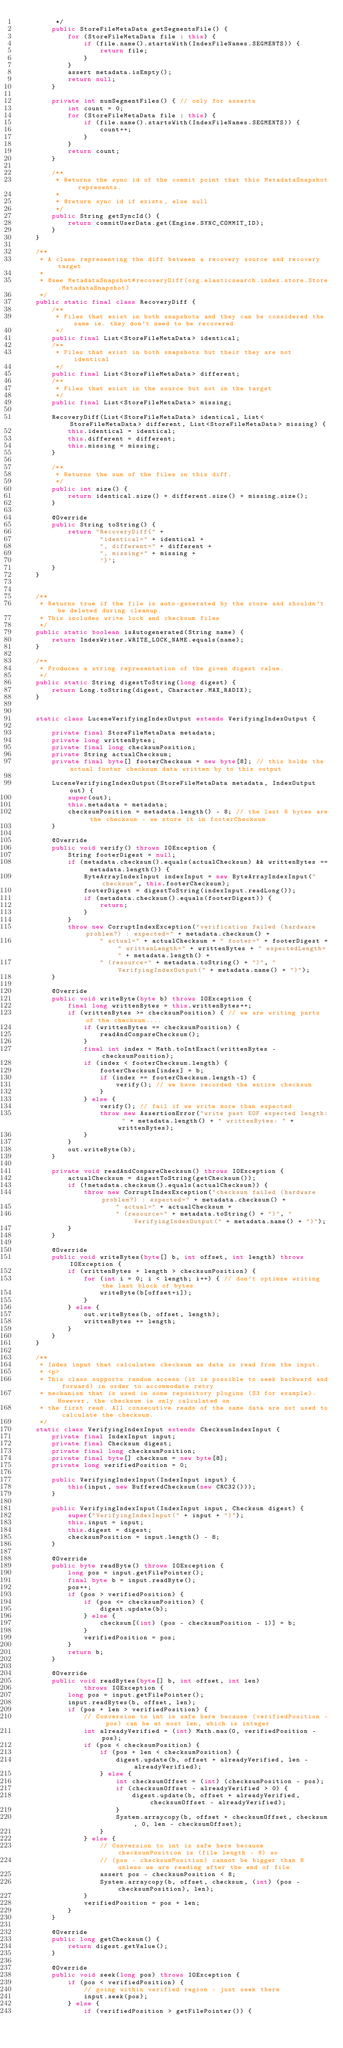Convert code to text. <code><loc_0><loc_0><loc_500><loc_500><_Java_>         */
        public StoreFileMetaData getSegmentsFile() {
            for (StoreFileMetaData file : this) {
                if (file.name().startsWith(IndexFileNames.SEGMENTS)) {
                    return file;
                }
            }
            assert metadata.isEmpty();
            return null;
        }

        private int numSegmentFiles() { // only for asserts
            int count = 0;
            for (StoreFileMetaData file : this) {
                if (file.name().startsWith(IndexFileNames.SEGMENTS)) {
                    count++;
                }
            }
            return count;
        }

        /**
         * Returns the sync id of the commit point that this MetadataSnapshot represents.
         *
         * @return sync id if exists, else null
         */
        public String getSyncId() {
            return commitUserData.get(Engine.SYNC_COMMIT_ID);
        }
    }

    /**
     * A class representing the diff between a recovery source and recovery target
     *
     * @see MetadataSnapshot#recoveryDiff(org.elasticsearch.index.store.Store.MetadataSnapshot)
     */
    public static final class RecoveryDiff {
        /**
         * Files that exist in both snapshots and they can be considered the same ie. they don't need to be recovered
         */
        public final List<StoreFileMetaData> identical;
        /**
         * Files that exist in both snapshots but their they are not identical
         */
        public final List<StoreFileMetaData> different;
        /**
         * Files that exist in the source but not in the target
         */
        public final List<StoreFileMetaData> missing;

        RecoveryDiff(List<StoreFileMetaData> identical, List<StoreFileMetaData> different, List<StoreFileMetaData> missing) {
            this.identical = identical;
            this.different = different;
            this.missing = missing;
        }

        /**
         * Returns the sum of the files in this diff.
         */
        public int size() {
            return identical.size() + different.size() + missing.size();
        }

        @Override
        public String toString() {
            return "RecoveryDiff{" +
                    "identical=" + identical +
                    ", different=" + different +
                    ", missing=" + missing +
                    '}';
        }
    }


    /**
     * Returns true if the file is auto-generated by the store and shouldn't be deleted during cleanup.
     * This includes write lock and checksum files
     */
    public static boolean isAutogenerated(String name) {
        return IndexWriter.WRITE_LOCK_NAME.equals(name);
    }

    /**
     * Produces a string representation of the given digest value.
     */
    public static String digestToString(long digest) {
        return Long.toString(digest, Character.MAX_RADIX);
    }


    static class LuceneVerifyingIndexOutput extends VerifyingIndexOutput {

        private final StoreFileMetaData metadata;
        private long writtenBytes;
        private final long checksumPosition;
        private String actualChecksum;
        private final byte[] footerChecksum = new byte[8]; // this holds the actual footer checksum data written by to this output

        LuceneVerifyingIndexOutput(StoreFileMetaData metadata, IndexOutput out) {
            super(out);
            this.metadata = metadata;
            checksumPosition = metadata.length() - 8; // the last 8 bytes are the checksum - we store it in footerChecksum
        }

        @Override
        public void verify() throws IOException {
            String footerDigest = null;
            if (metadata.checksum().equals(actualChecksum) && writtenBytes == metadata.length()) {
                ByteArrayIndexInput indexInput = new ByteArrayIndexInput("checksum", this.footerChecksum);
                footerDigest = digestToString(indexInput.readLong());
                if (metadata.checksum().equals(footerDigest)) {
                    return;
                }
            }
            throw new CorruptIndexException("verification failed (hardware problem?) : expected=" + metadata.checksum() +
                    " actual=" + actualChecksum + " footer=" + footerDigest +" writtenLength=" + writtenBytes + " expectedLength=" + metadata.length() +
                    " (resource=" + metadata.toString() + ")", "VerifyingIndexOutput(" + metadata.name() + ")");
        }

        @Override
        public void writeByte(byte b) throws IOException {
            final long writtenBytes = this.writtenBytes++;
            if (writtenBytes >= checksumPosition) { // we are writing parts of the checksum....
                if (writtenBytes == checksumPosition) {
                    readAndCompareChecksum();
                }
                final int index = Math.toIntExact(writtenBytes - checksumPosition);
                if (index < footerChecksum.length) {
                    footerChecksum[index] = b;
                    if (index == footerChecksum.length-1) {
                        verify(); // we have recorded the entire checksum
                    }
                } else {
                    verify(); // fail if we write more than expected
                    throw new AssertionError("write past EOF expected length: " + metadata.length() + " writtenBytes: " + writtenBytes);
                }
            }
            out.writeByte(b);
        }

        private void readAndCompareChecksum() throws IOException {
            actualChecksum = digestToString(getChecksum());
            if (!metadata.checksum().equals(actualChecksum)) {
                throw new CorruptIndexException("checksum failed (hardware problem?) : expected=" + metadata.checksum() +
                        " actual=" + actualChecksum +
                        " (resource=" + metadata.toString() + ")", "VerifyingIndexOutput(" + metadata.name() + ")");
            }
        }

        @Override
        public void writeBytes(byte[] b, int offset, int length) throws IOException {
            if (writtenBytes + length > checksumPosition) {
                for (int i = 0; i < length; i++) { // don't optimze writing the last block of bytes
                    writeByte(b[offset+i]);
                }
            } else {
                out.writeBytes(b, offset, length);
                writtenBytes += length;
            }
        }
    }

    /**
     * Index input that calculates checksum as data is read from the input.
     * <p>
     * This class supports random access (it is possible to seek backward and forward) in order to accommodate retry
     * mechanism that is used in some repository plugins (S3 for example). However, the checksum is only calculated on
     * the first read. All consecutive reads of the same data are not used to calculate the checksum.
     */
    static class VerifyingIndexInput extends ChecksumIndexInput {
        private final IndexInput input;
        private final Checksum digest;
        private final long checksumPosition;
        private final byte[] checksum = new byte[8];
        private long verifiedPosition = 0;

        public VerifyingIndexInput(IndexInput input) {
            this(input, new BufferedChecksum(new CRC32()));
        }

        public VerifyingIndexInput(IndexInput input, Checksum digest) {
            super("VerifyingIndexInput(" + input + ")");
            this.input = input;
            this.digest = digest;
            checksumPosition = input.length() - 8;
        }

        @Override
        public byte readByte() throws IOException {
            long pos = input.getFilePointer();
            final byte b = input.readByte();
            pos++;
            if (pos > verifiedPosition) {
                if (pos <= checksumPosition) {
                    digest.update(b);
                } else {
                    checksum[(int) (pos - checksumPosition - 1)] = b;
                }
                verifiedPosition = pos;
            }
            return b;
        }

        @Override
        public void readBytes(byte[] b, int offset, int len)
                throws IOException {
            long pos = input.getFilePointer();
            input.readBytes(b, offset, len);
            if (pos + len > verifiedPosition) {
                // Conversion to int is safe here because (verifiedPosition - pos) can be at most len, which is integer
                int alreadyVerified = (int) Math.max(0, verifiedPosition - pos);
                if (pos < checksumPosition) {
                    if (pos + len < checksumPosition) {
                        digest.update(b, offset + alreadyVerified, len - alreadyVerified);
                    } else {
                        int checksumOffset = (int) (checksumPosition - pos);
                        if (checksumOffset - alreadyVerified > 0) {
                            digest.update(b, offset + alreadyVerified, checksumOffset - alreadyVerified);
                        }
                        System.arraycopy(b, offset + checksumOffset, checksum, 0, len - checksumOffset);
                    }
                } else {
                    // Conversion to int is safe here because checksumPosition is (file length - 8) so
                    // (pos - checksumPosition) cannot be bigger than 8 unless we are reading after the end of file
                    assert pos - checksumPosition < 8;
                    System.arraycopy(b, offset, checksum, (int) (pos - checksumPosition), len);
                }
                verifiedPosition = pos + len;
            }
        }

        @Override
        public long getChecksum() {
            return digest.getValue();
        }

        @Override
        public void seek(long pos) throws IOException {
            if (pos < verifiedPosition) {
                // going within verified region - just seek there
                input.seek(pos);
            } else {
                if (verifiedPosition > getFilePointer()) {</code> 